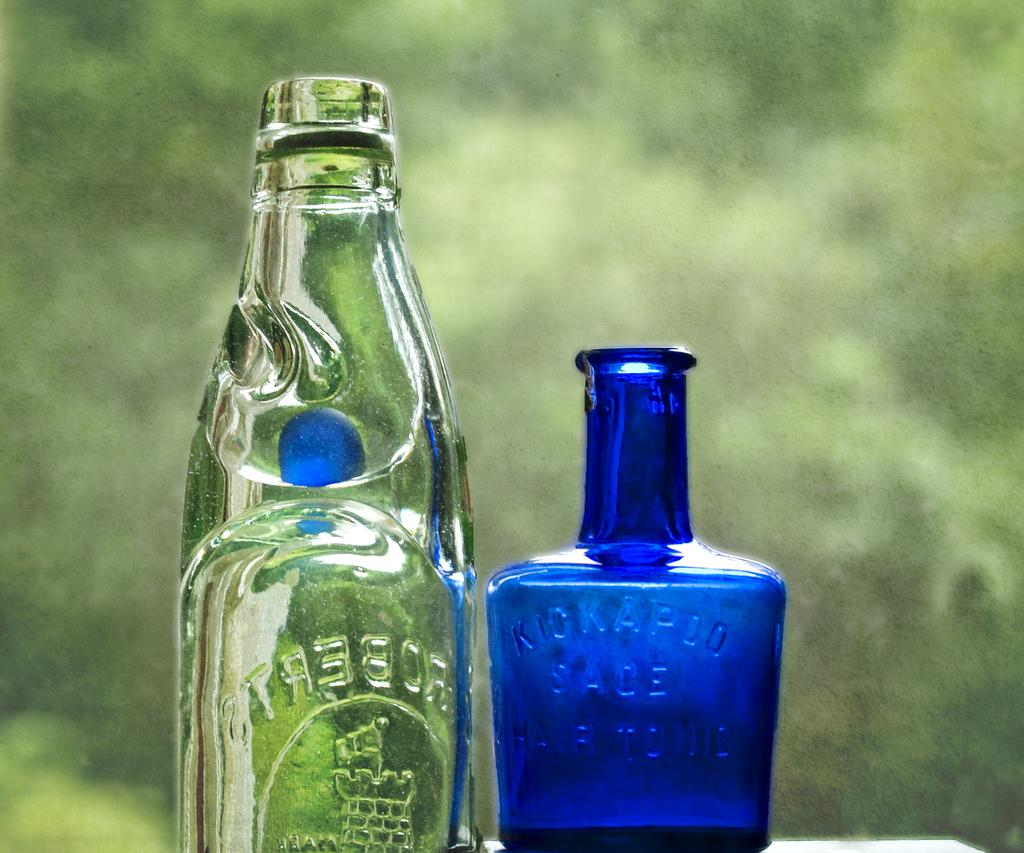Provide a one-sentence caption for the provided image. A blue Kickapoo bottle stands next to a clear, taller bottle. 